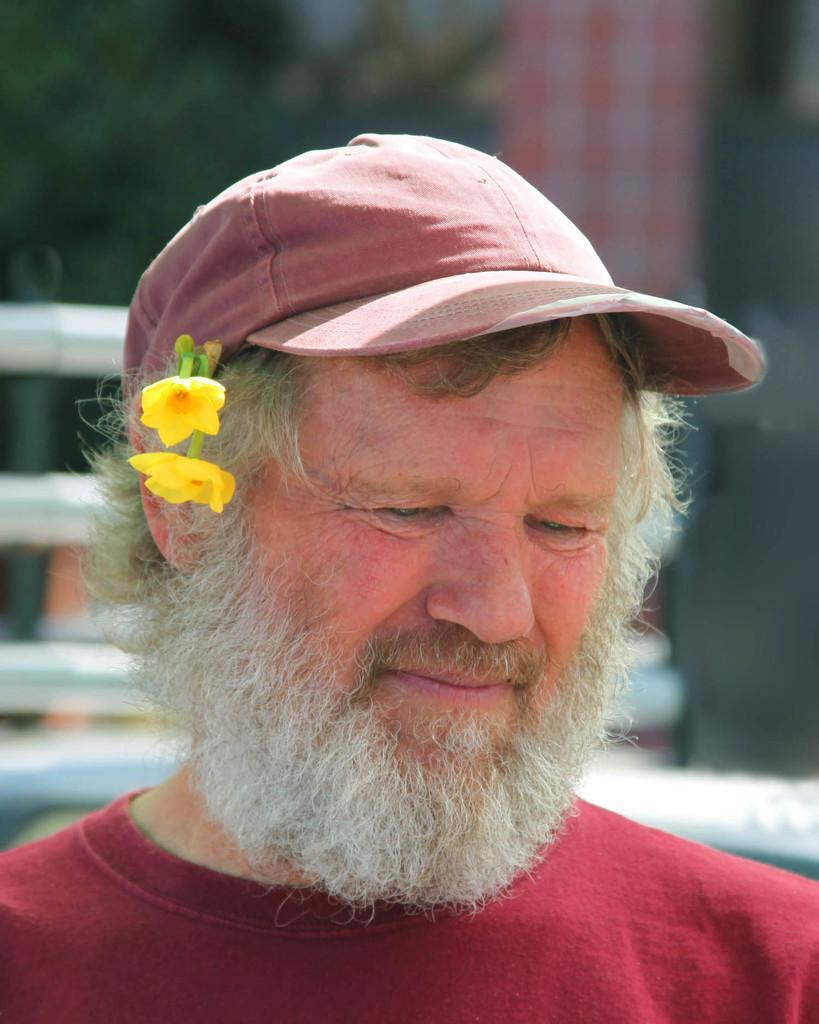In one or two sentences, can you explain what this image depicts? In this image there is a man. He is wearing a cap and we can see flowers in his ears. In the background there are rods and trees. 